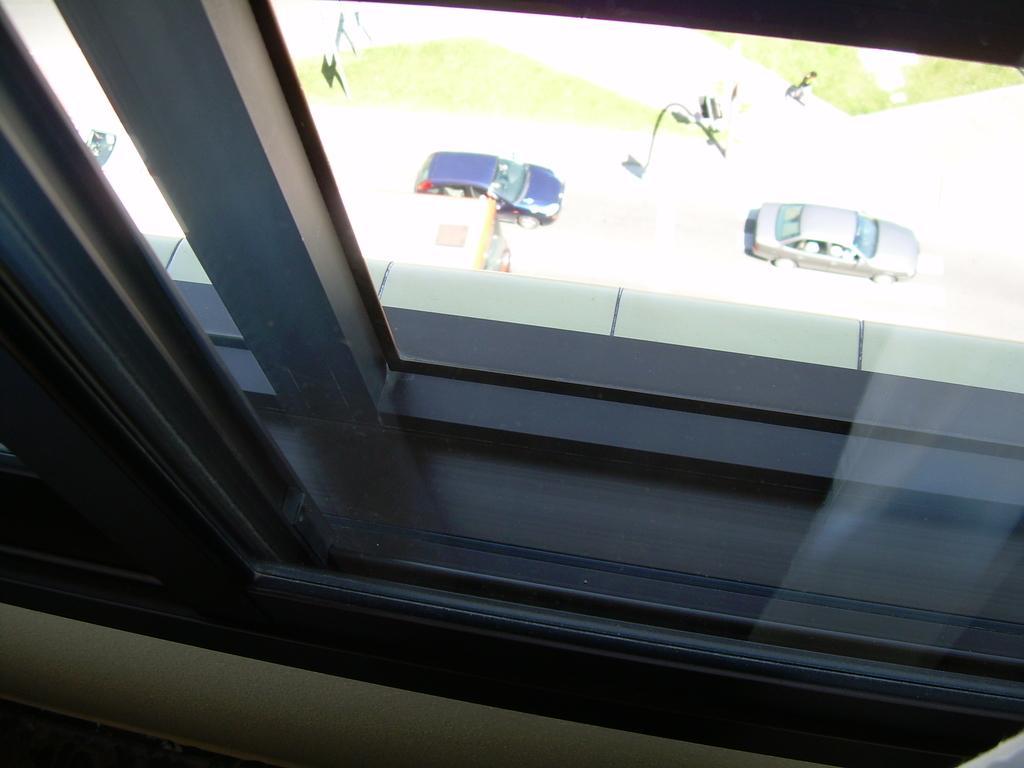Describe this image in one or two sentences. In this image I can see a glass window. We can see vehicles on the road. 